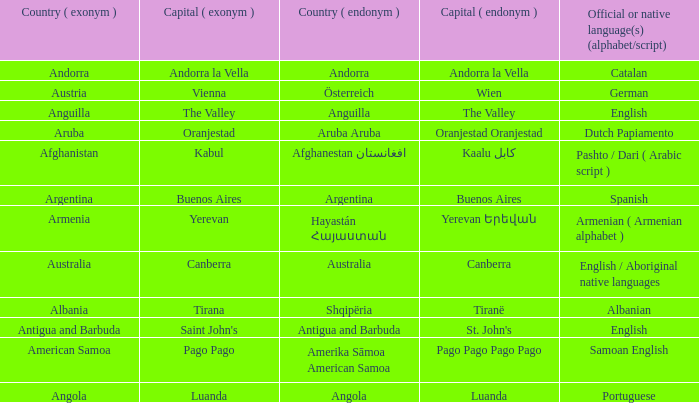What is the local name given to the city of Canberra? Canberra. 